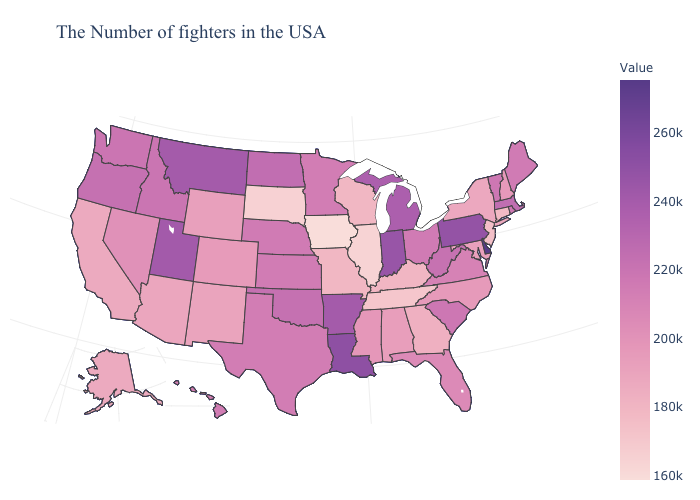Does Delaware have the highest value in the USA?
Write a very short answer. Yes. Which states have the highest value in the USA?
Answer briefly. Delaware. Which states hav the highest value in the West?
Be succinct. Utah. Which states have the lowest value in the USA?
Write a very short answer. Iowa. 